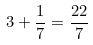<formula> <loc_0><loc_0><loc_500><loc_500>3 + \frac { 1 } { 7 } = \frac { 2 2 } { 7 }</formula> 